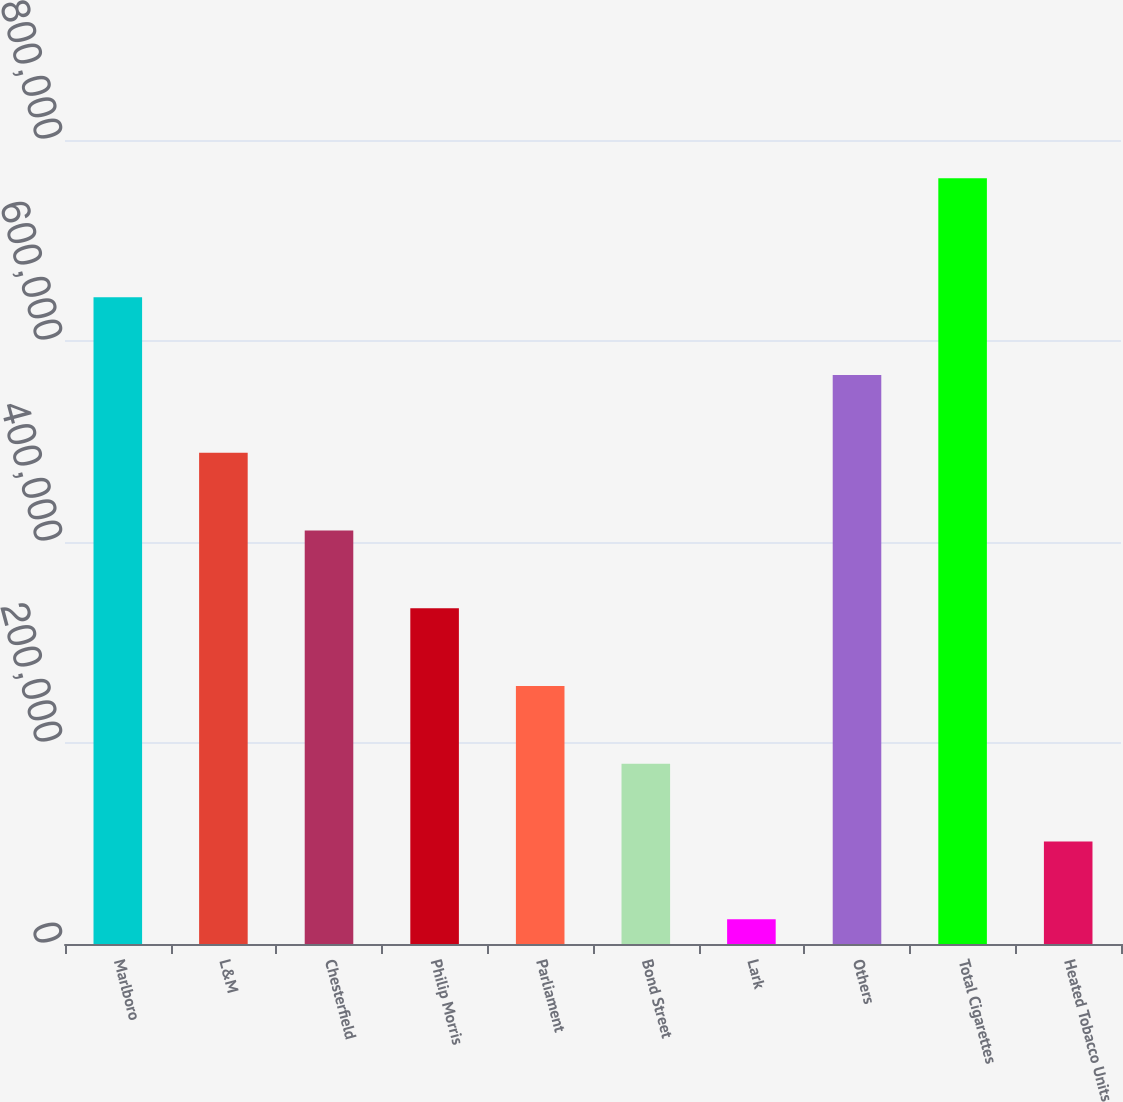<chart> <loc_0><loc_0><loc_500><loc_500><bar_chart><fcel>Marlboro<fcel>L&M<fcel>Chesterfield<fcel>Philip Morris<fcel>Parliament<fcel>Bond Street<fcel>Lark<fcel>Others<fcel>Total Cigarettes<fcel>Heated Tobacco Units<nl><fcel>643428<fcel>488703<fcel>411341<fcel>333979<fcel>256617<fcel>179254<fcel>24530<fcel>566065<fcel>761926<fcel>101892<nl></chart> 